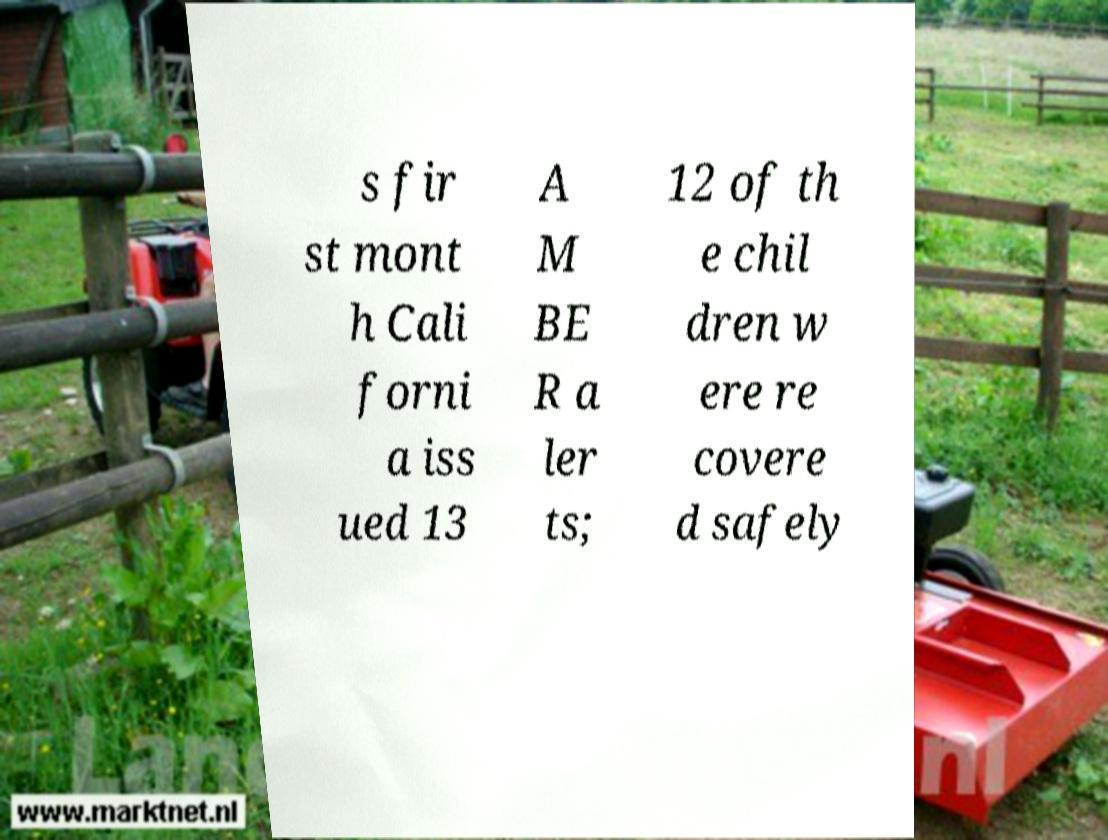What messages or text are displayed in this image? I need them in a readable, typed format. s fir st mont h Cali forni a iss ued 13 A M BE R a ler ts; 12 of th e chil dren w ere re covere d safely 